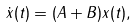Convert formula to latex. <formula><loc_0><loc_0><loc_500><loc_500>\dot { x } ( t ) = ( A + B ) x ( t ) ,</formula> 